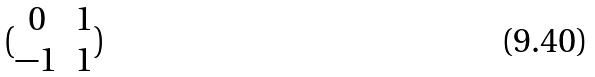<formula> <loc_0><loc_0><loc_500><loc_500>( \begin{matrix} 0 & 1 \\ - 1 & 1 \end{matrix} )</formula> 